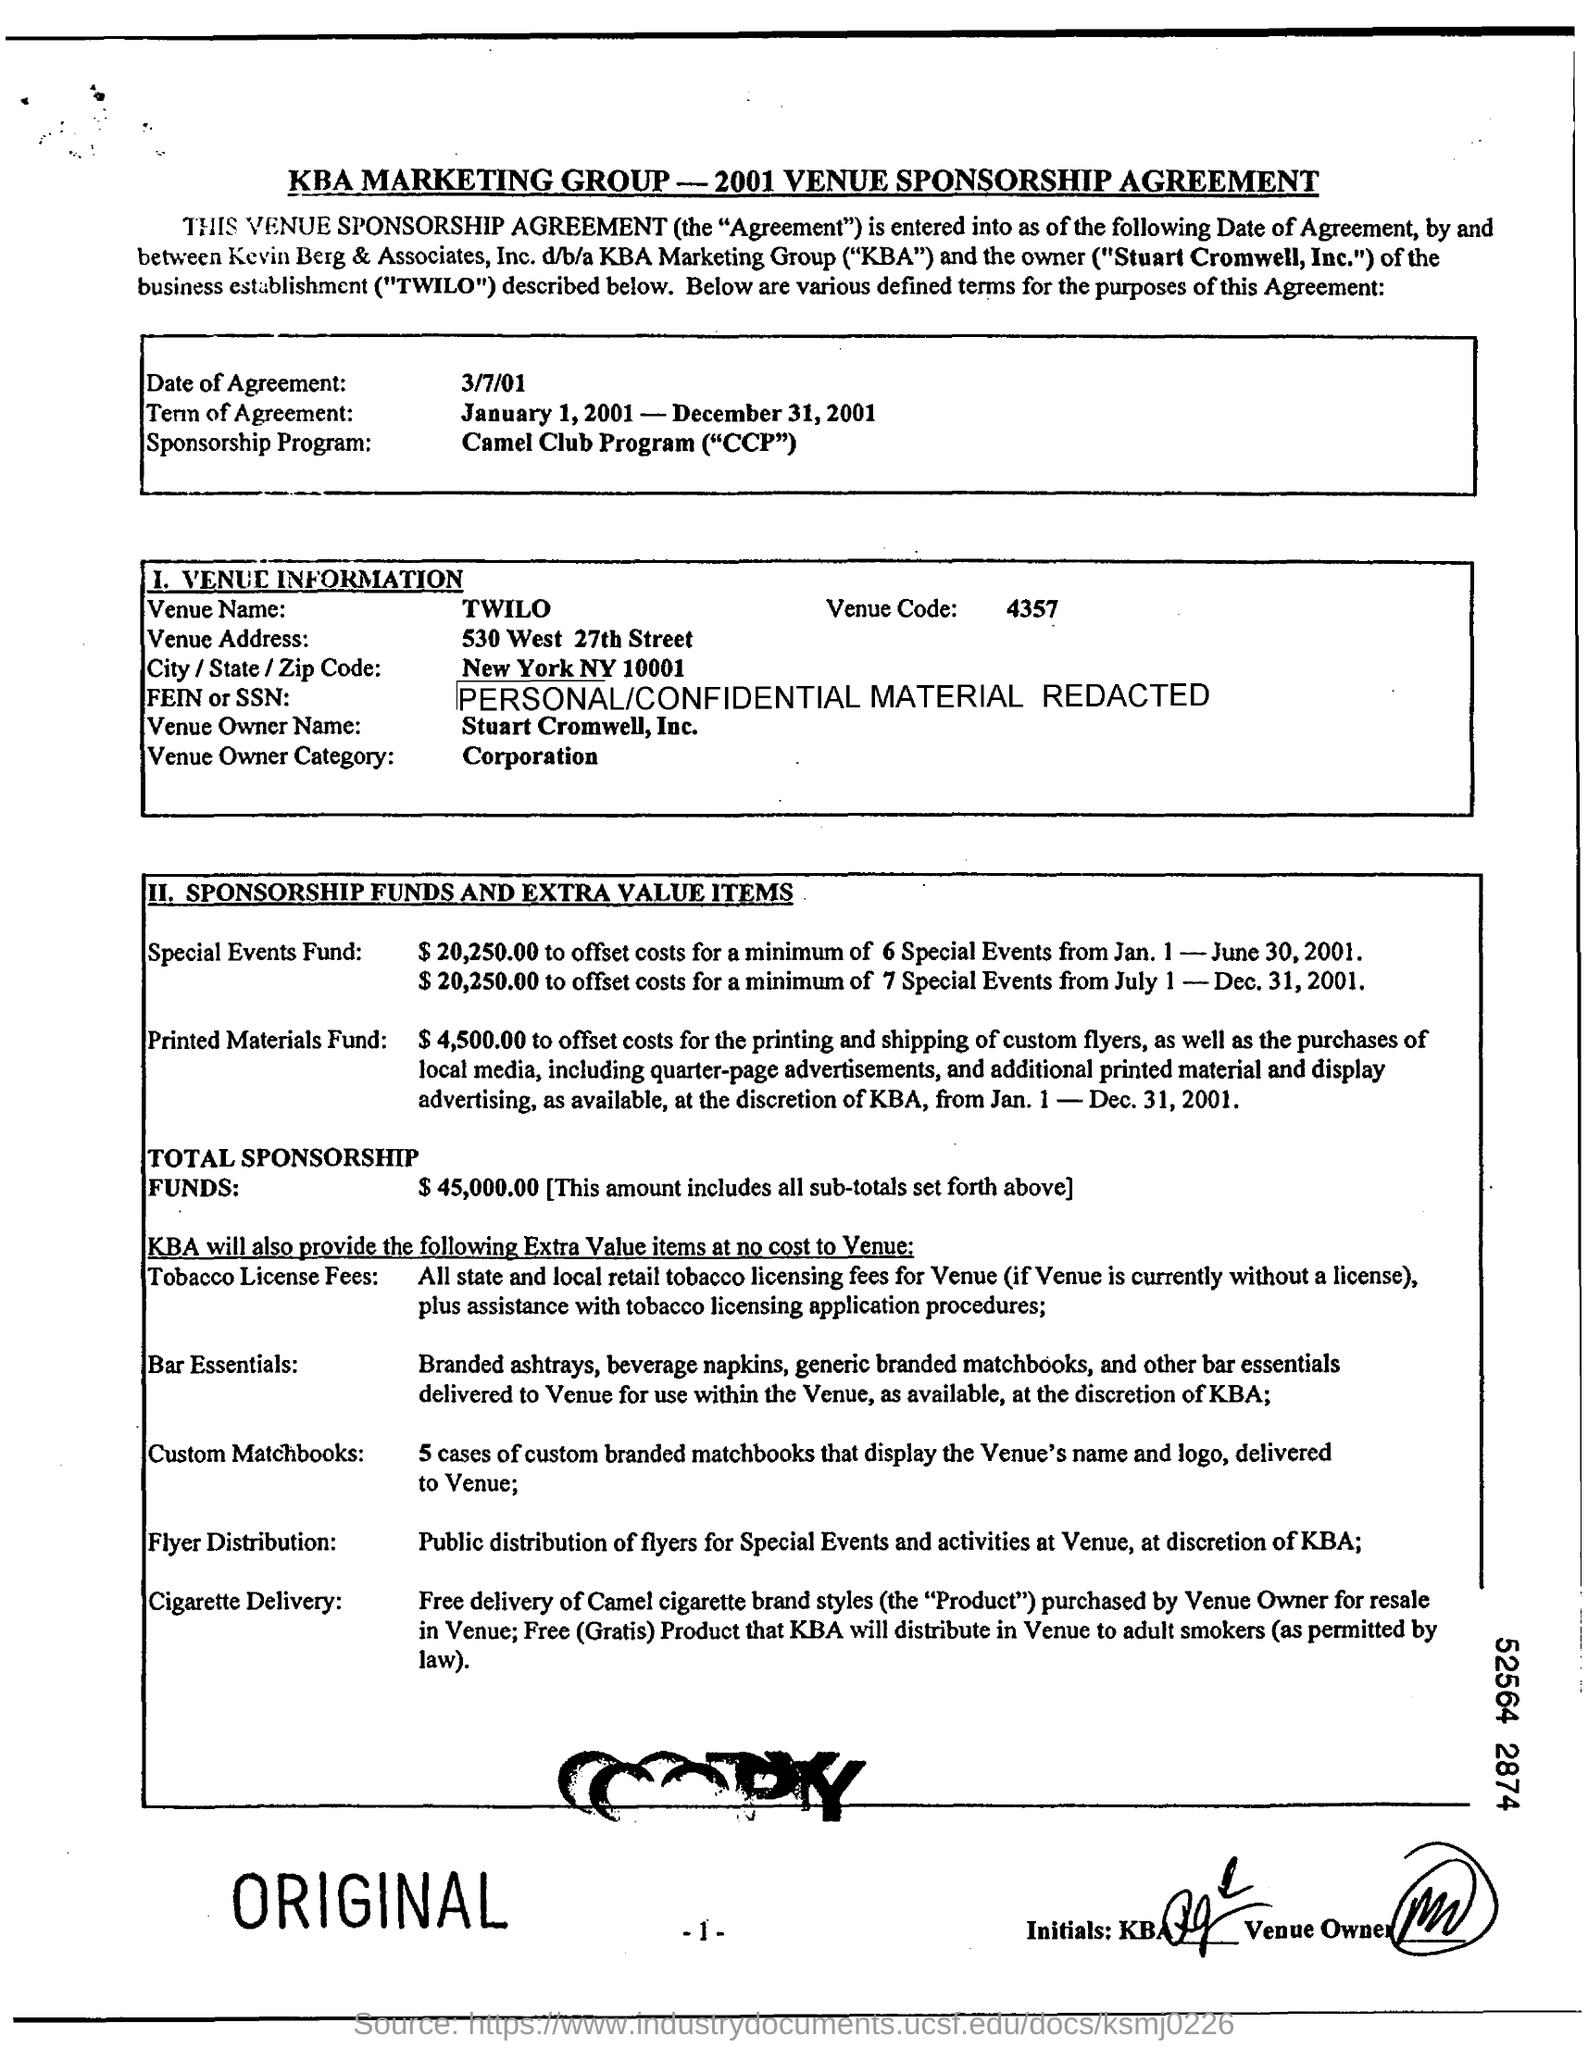What date was the agreement signed? The agreement was signed on March 7, 2001. 